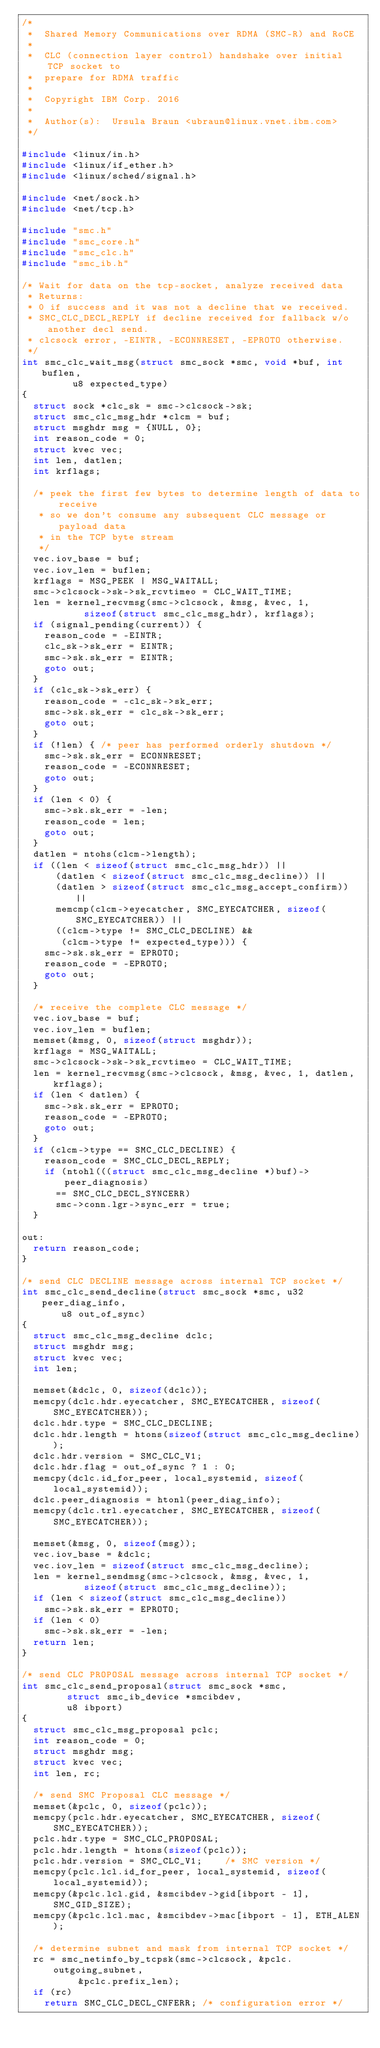<code> <loc_0><loc_0><loc_500><loc_500><_C_>/*
 *  Shared Memory Communications over RDMA (SMC-R) and RoCE
 *
 *  CLC (connection layer control) handshake over initial TCP socket to
 *  prepare for RDMA traffic
 *
 *  Copyright IBM Corp. 2016
 *
 *  Author(s):  Ursula Braun <ubraun@linux.vnet.ibm.com>
 */

#include <linux/in.h>
#include <linux/if_ether.h>
#include <linux/sched/signal.h>

#include <net/sock.h>
#include <net/tcp.h>

#include "smc.h"
#include "smc_core.h"
#include "smc_clc.h"
#include "smc_ib.h"

/* Wait for data on the tcp-socket, analyze received data
 * Returns:
 * 0 if success and it was not a decline that we received.
 * SMC_CLC_DECL_REPLY if decline received for fallback w/o another decl send.
 * clcsock error, -EINTR, -ECONNRESET, -EPROTO otherwise.
 */
int smc_clc_wait_msg(struct smc_sock *smc, void *buf, int buflen,
		     u8 expected_type)
{
	struct sock *clc_sk = smc->clcsock->sk;
	struct smc_clc_msg_hdr *clcm = buf;
	struct msghdr msg = {NULL, 0};
	int reason_code = 0;
	struct kvec vec;
	int len, datlen;
	int krflags;

	/* peek the first few bytes to determine length of data to receive
	 * so we don't consume any subsequent CLC message or payload data
	 * in the TCP byte stream
	 */
	vec.iov_base = buf;
	vec.iov_len = buflen;
	krflags = MSG_PEEK | MSG_WAITALL;
	smc->clcsock->sk->sk_rcvtimeo = CLC_WAIT_TIME;
	len = kernel_recvmsg(smc->clcsock, &msg, &vec, 1,
			     sizeof(struct smc_clc_msg_hdr), krflags);
	if (signal_pending(current)) {
		reason_code = -EINTR;
		clc_sk->sk_err = EINTR;
		smc->sk.sk_err = EINTR;
		goto out;
	}
	if (clc_sk->sk_err) {
		reason_code = -clc_sk->sk_err;
		smc->sk.sk_err = clc_sk->sk_err;
		goto out;
	}
	if (!len) { /* peer has performed orderly shutdown */
		smc->sk.sk_err = ECONNRESET;
		reason_code = -ECONNRESET;
		goto out;
	}
	if (len < 0) {
		smc->sk.sk_err = -len;
		reason_code = len;
		goto out;
	}
	datlen = ntohs(clcm->length);
	if ((len < sizeof(struct smc_clc_msg_hdr)) ||
	    (datlen < sizeof(struct smc_clc_msg_decline)) ||
	    (datlen > sizeof(struct smc_clc_msg_accept_confirm)) ||
	    memcmp(clcm->eyecatcher, SMC_EYECATCHER, sizeof(SMC_EYECATCHER)) ||
	    ((clcm->type != SMC_CLC_DECLINE) &&
	     (clcm->type != expected_type))) {
		smc->sk.sk_err = EPROTO;
		reason_code = -EPROTO;
		goto out;
	}

	/* receive the complete CLC message */
	vec.iov_base = buf;
	vec.iov_len = buflen;
	memset(&msg, 0, sizeof(struct msghdr));
	krflags = MSG_WAITALL;
	smc->clcsock->sk->sk_rcvtimeo = CLC_WAIT_TIME;
	len = kernel_recvmsg(smc->clcsock, &msg, &vec, 1, datlen, krflags);
	if (len < datlen) {
		smc->sk.sk_err = EPROTO;
		reason_code = -EPROTO;
		goto out;
	}
	if (clcm->type == SMC_CLC_DECLINE) {
		reason_code = SMC_CLC_DECL_REPLY;
		if (ntohl(((struct smc_clc_msg_decline *)buf)->peer_diagnosis)
			== SMC_CLC_DECL_SYNCERR)
			smc->conn.lgr->sync_err = true;
	}

out:
	return reason_code;
}

/* send CLC DECLINE message across internal TCP socket */
int smc_clc_send_decline(struct smc_sock *smc, u32 peer_diag_info,
			 u8 out_of_sync)
{
	struct smc_clc_msg_decline dclc;
	struct msghdr msg;
	struct kvec vec;
	int len;

	memset(&dclc, 0, sizeof(dclc));
	memcpy(dclc.hdr.eyecatcher, SMC_EYECATCHER, sizeof(SMC_EYECATCHER));
	dclc.hdr.type = SMC_CLC_DECLINE;
	dclc.hdr.length = htons(sizeof(struct smc_clc_msg_decline));
	dclc.hdr.version = SMC_CLC_V1;
	dclc.hdr.flag = out_of_sync ? 1 : 0;
	memcpy(dclc.id_for_peer, local_systemid, sizeof(local_systemid));
	dclc.peer_diagnosis = htonl(peer_diag_info);
	memcpy(dclc.trl.eyecatcher, SMC_EYECATCHER, sizeof(SMC_EYECATCHER));

	memset(&msg, 0, sizeof(msg));
	vec.iov_base = &dclc;
	vec.iov_len = sizeof(struct smc_clc_msg_decline);
	len = kernel_sendmsg(smc->clcsock, &msg, &vec, 1,
			     sizeof(struct smc_clc_msg_decline));
	if (len < sizeof(struct smc_clc_msg_decline))
		smc->sk.sk_err = EPROTO;
	if (len < 0)
		smc->sk.sk_err = -len;
	return len;
}

/* send CLC PROPOSAL message across internal TCP socket */
int smc_clc_send_proposal(struct smc_sock *smc,
			  struct smc_ib_device *smcibdev,
			  u8 ibport)
{
	struct smc_clc_msg_proposal pclc;
	int reason_code = 0;
	struct msghdr msg;
	struct kvec vec;
	int len, rc;

	/* send SMC Proposal CLC message */
	memset(&pclc, 0, sizeof(pclc));
	memcpy(pclc.hdr.eyecatcher, SMC_EYECATCHER, sizeof(SMC_EYECATCHER));
	pclc.hdr.type = SMC_CLC_PROPOSAL;
	pclc.hdr.length = htons(sizeof(pclc));
	pclc.hdr.version = SMC_CLC_V1;		/* SMC version */
	memcpy(pclc.lcl.id_for_peer, local_systemid, sizeof(local_systemid));
	memcpy(&pclc.lcl.gid, &smcibdev->gid[ibport - 1], SMC_GID_SIZE);
	memcpy(&pclc.lcl.mac, &smcibdev->mac[ibport - 1], ETH_ALEN);

	/* determine subnet and mask from internal TCP socket */
	rc = smc_netinfo_by_tcpsk(smc->clcsock, &pclc.outgoing_subnet,
				  &pclc.prefix_len);
	if (rc)
		return SMC_CLC_DECL_CNFERR; /* configuration error */</code> 